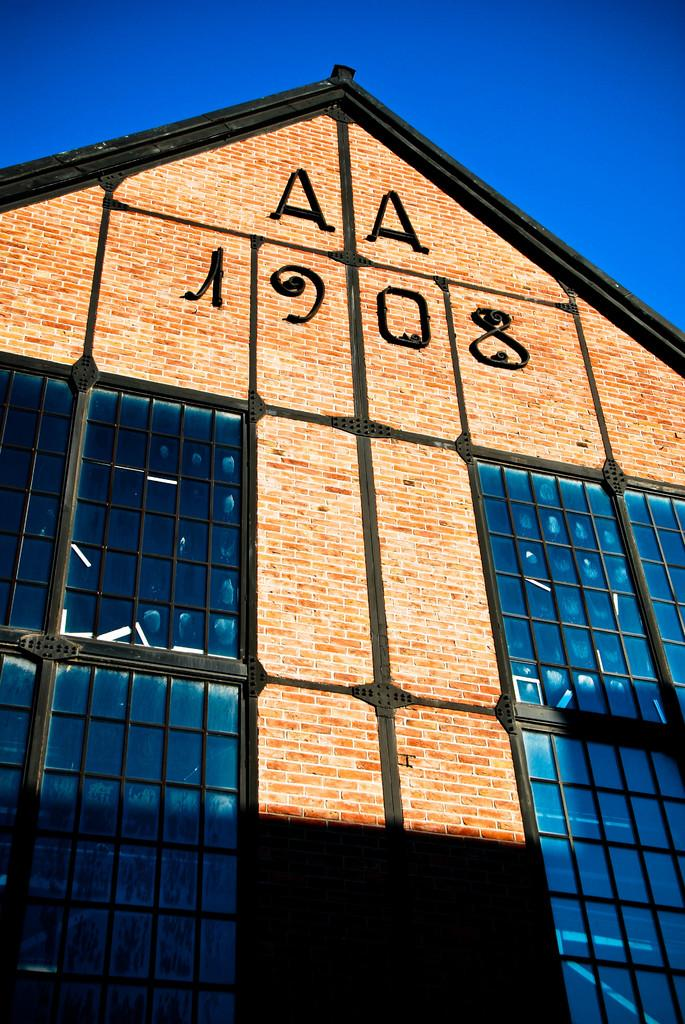Where was the image taken? The image is taken outdoors. What can be seen at the top of the image? The sky is visible at the top of the image. What is the main structure in the middle of the image? There is a building in the middle of the image. What are the characteristics of the building? The building has walls and windows. Is there any text visible on the building? Yes, there is text on the wall of the building. What type of force is being applied to the sheet in the image? There is no sheet present in the image, so no force can be applied to it. 